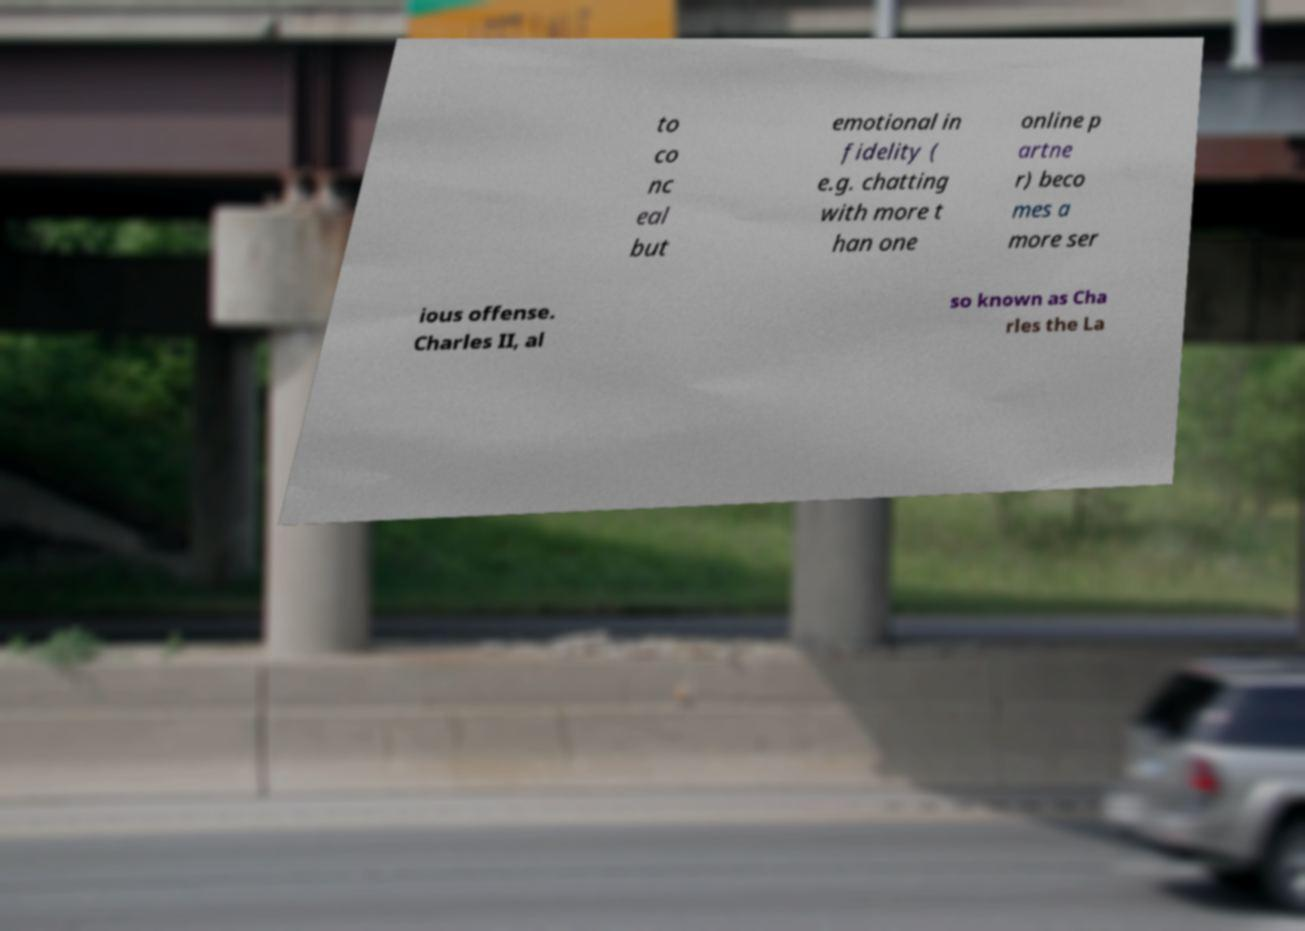Please identify and transcribe the text found in this image. to co nc eal but emotional in fidelity ( e.g. chatting with more t han one online p artne r) beco mes a more ser ious offense. Charles II, al so known as Cha rles the La 